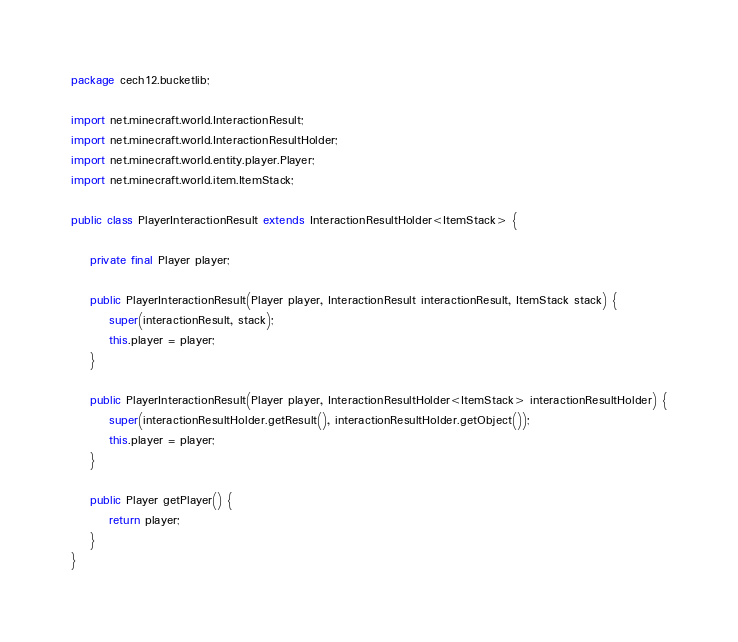<code> <loc_0><loc_0><loc_500><loc_500><_Java_>package cech12.bucketlib;

import net.minecraft.world.InteractionResult;
import net.minecraft.world.InteractionResultHolder;
import net.minecraft.world.entity.player.Player;
import net.minecraft.world.item.ItemStack;

public class PlayerInteractionResult extends InteractionResultHolder<ItemStack> {

    private final Player player;

    public PlayerInteractionResult(Player player, InteractionResult interactionResult, ItemStack stack) {
        super(interactionResult, stack);
        this.player = player;
    }

    public PlayerInteractionResult(Player player, InteractionResultHolder<ItemStack> interactionResultHolder) {
        super(interactionResultHolder.getResult(), interactionResultHolder.getObject());
        this.player = player;
    }

    public Player getPlayer() {
        return player;
    }
}
</code> 